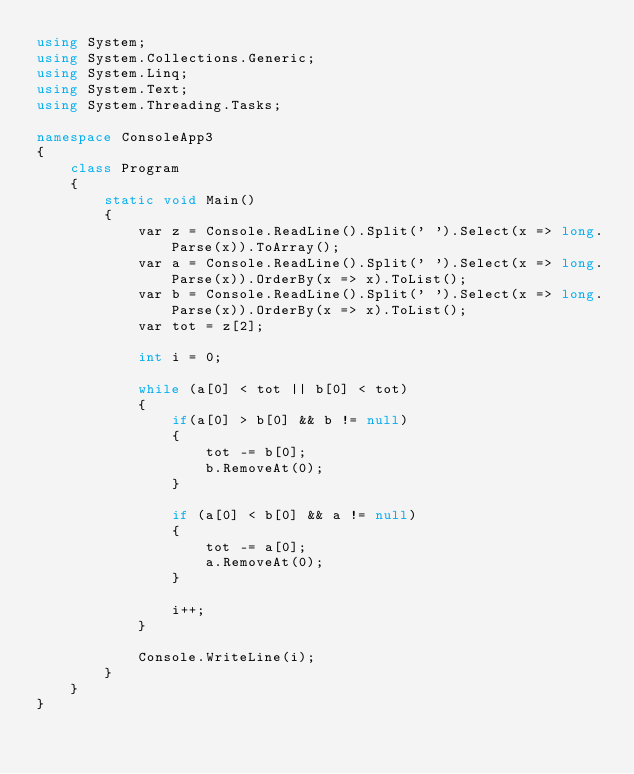<code> <loc_0><loc_0><loc_500><loc_500><_C#_>using System;
using System.Collections.Generic;
using System.Linq;
using System.Text;
using System.Threading.Tasks;

namespace ConsoleApp3
{
    class Program
    {
        static void Main()
        {
            var z = Console.ReadLine().Split(' ').Select(x => long.Parse(x)).ToArray();
            var a = Console.ReadLine().Split(' ').Select(x => long.Parse(x)).OrderBy(x => x).ToList();
            var b = Console.ReadLine().Split(' ').Select(x => long.Parse(x)).OrderBy(x => x).ToList();
            var tot = z[2];
            
            int i = 0;

            while (a[0] < tot || b[0] < tot)
            {
                if(a[0] > b[0] && b != null)
                {
                    tot -= b[0];
                    b.RemoveAt(0);
                }

                if (a[0] < b[0] && a != null)
                {
                    tot -= a[0];
                    a.RemoveAt(0);
                }

                i++;
            }
            
            Console.WriteLine(i);
        }
    }
}
</code> 